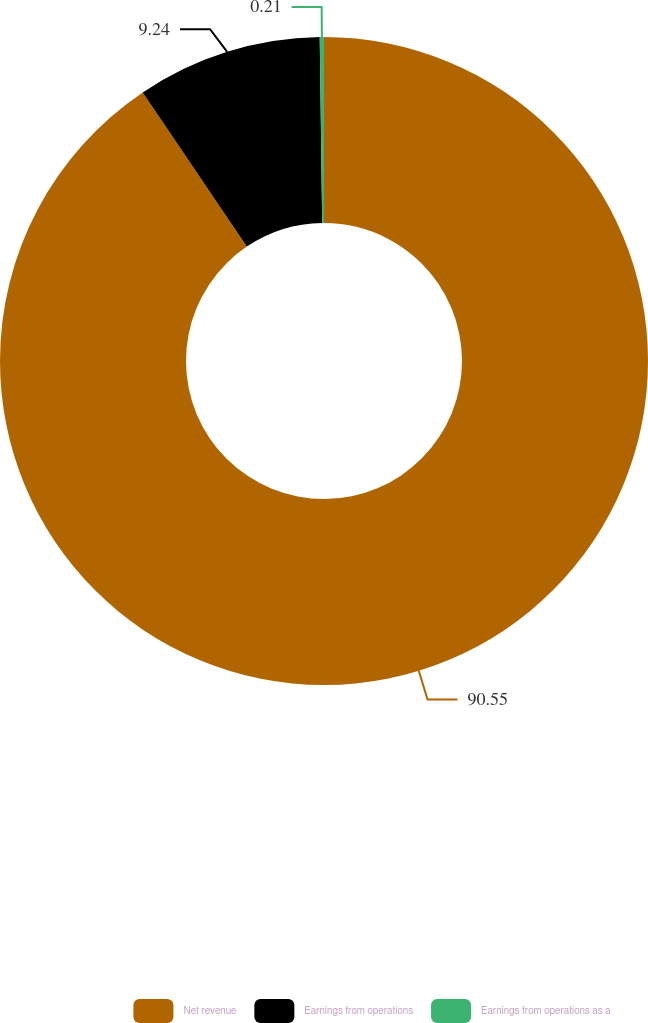<chart> <loc_0><loc_0><loc_500><loc_500><pie_chart><fcel>Net revenue<fcel>Earnings from operations<fcel>Earnings from operations as a<nl><fcel>90.54%<fcel>9.24%<fcel>0.21%<nl></chart> 